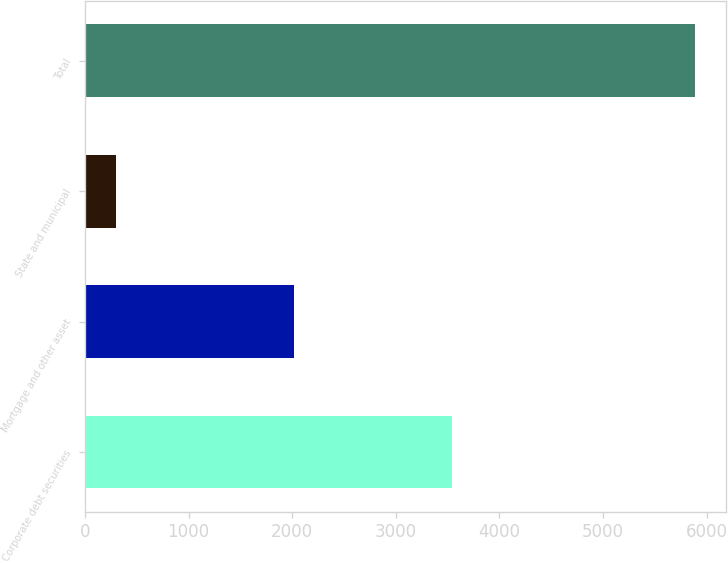Convert chart. <chart><loc_0><loc_0><loc_500><loc_500><bar_chart><fcel>Corporate debt securities<fcel>Mortgage and other asset<fcel>State and municipal<fcel>Total<nl><fcel>3544<fcel>2014<fcel>295<fcel>5891<nl></chart> 